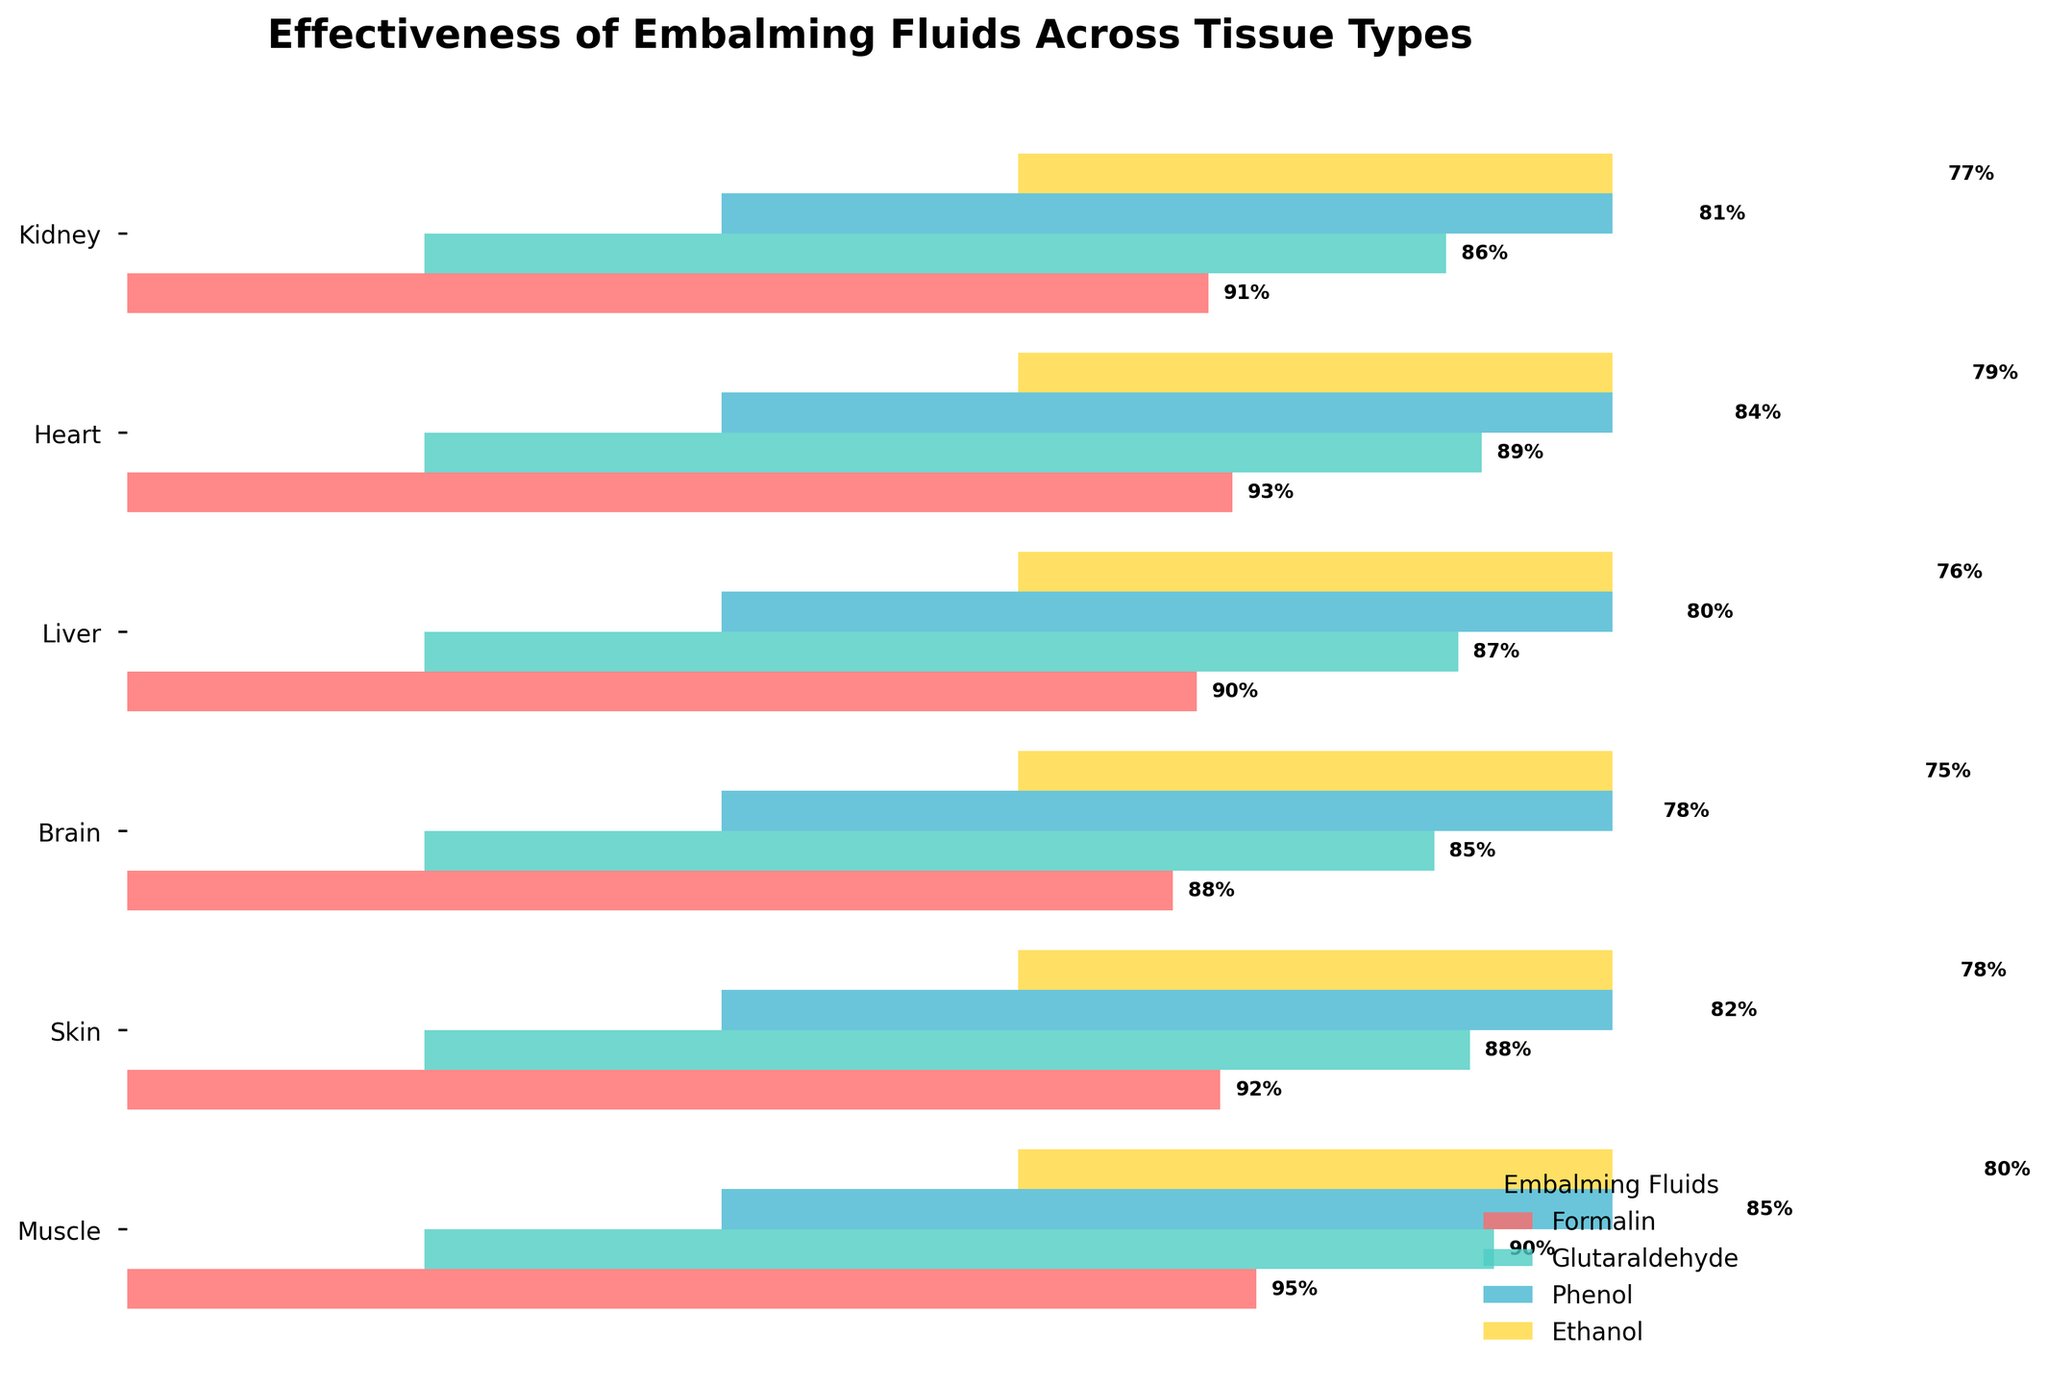What is the title of the figure? The title of the figure is the text that appears at the top. It specifies the main subject of the figure. In this case, the title indicates the overall theme of the chart.
Answer: "Effectiveness of Embalming Fluids Across Tissue Types" Which tissue type shows the highest effectiveness for Formalin? To find the highest effectiveness, look at the Formalin bar for each tissue type and find the one with the highest percentage.
Answer: Muscle How does the effectiveness of Glutaraldehyde compare to Ethanol for the Brain tissue? Compare the bar lengths for Glutaraldehyde and Ethanol specific to the Brain tissue. Glutaraldehyde is higher at 85%, while Ethanol is lower at 75%.
Answer: Glutaraldehyde is more effective What is the average effectiveness of Phenol across all tissue types? Calculate the average by summing the effectiveness percentages for Phenol across Muscle, Skin, Brain, Liver, Heart, and Kidney. (85 + 82 + 78 + 80 + 84 + 81)/6 = 81.7
Answer: 81.7% Which embalming fluid is least effective for the Heart tissue? Check the lengths of the bars for the Heart tissue and identify the lowest percentage. Ethanol has the lowest value at 79%.
Answer: Ethanol How much more effective is Formalin compared to Ethanol for the Liver tissue? Subtract the effectiveness percentage of Ethanol from that of Formalin for the Liver tissue. (90 - 76 = 14)
Answer: 14% Which embalming fluid shows the most consistent effectiveness across all tissue types (smallest range of effectiveness values)? To determine consistency, find the range of percentages for each fluid across all tissue types (max value - min value). Compare the ranges.
Answer: Formalin (range: 7%) For which tissue type do all embalming fluids have the effectiveness between 75% and 90%? Look for a tissue where all fluids' effectiveness percentages fall within the 75%-90% range. All fluids for the Kidney tissue fall into this range.
Answer: Kidney 